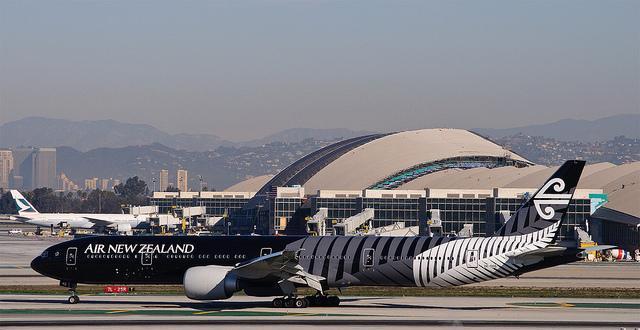How many airplanes can you see?
Give a very brief answer. 2. 